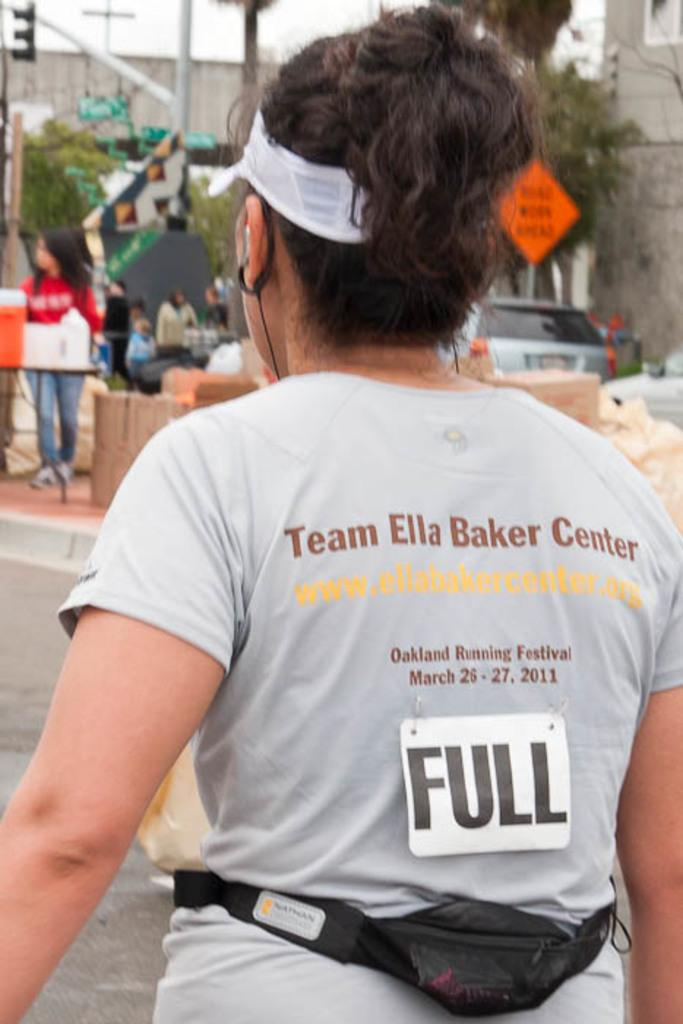<image>
Render a clear and concise summary of the photo. People are taking part in the Oakland Running Festival 